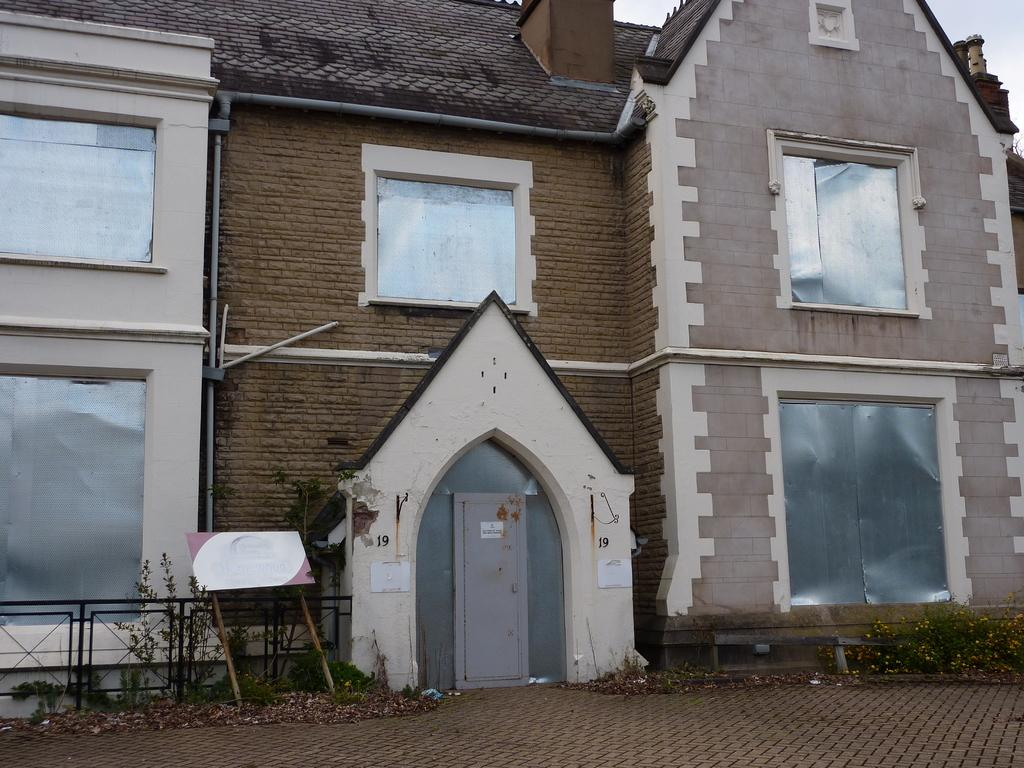What is the main structure in the image? There is a building in the image. What is located in front of the building? There are plants and a board in front of the building. How can the building be accessed? The building has a door at its center. What can be seen in the background of the image? The sky is visible in the background of the image. What type of gold object is hanging from the door of the building in the image? There is no gold object hanging from the door of the building in the image. What drink is being served to the people in front of the building? There are no people or drinks present in the image. 